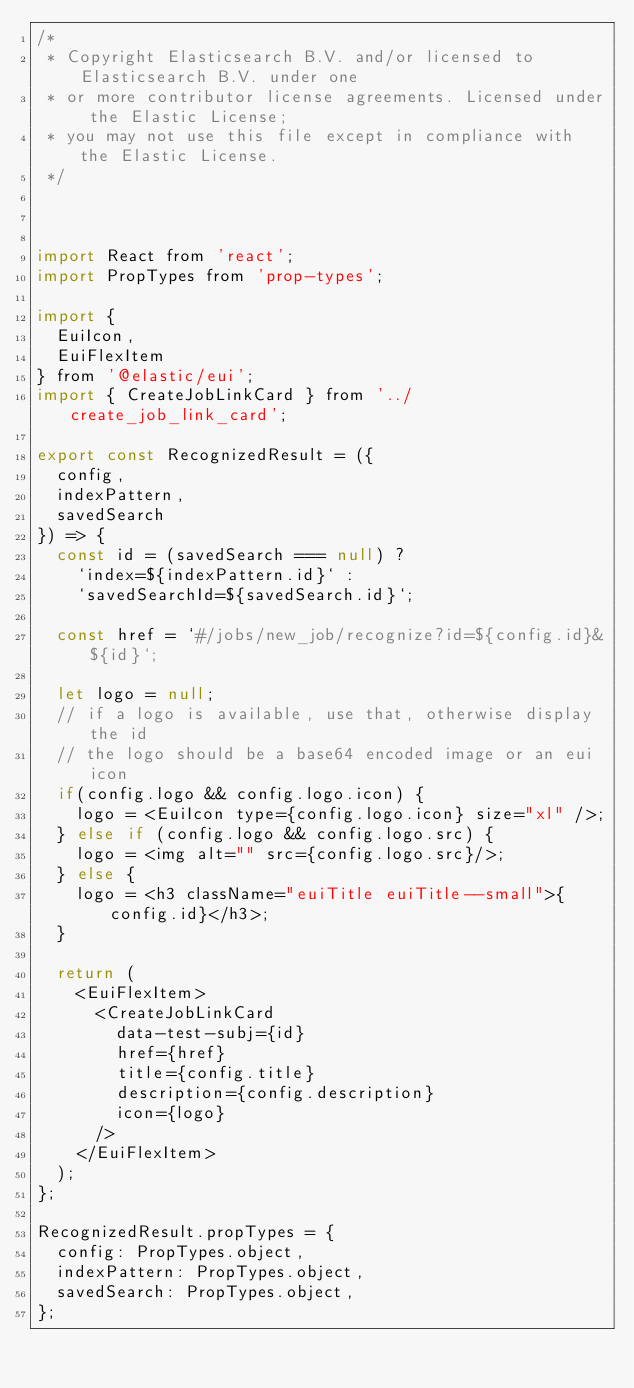<code> <loc_0><loc_0><loc_500><loc_500><_JavaScript_>/*
 * Copyright Elasticsearch B.V. and/or licensed to Elasticsearch B.V. under one
 * or more contributor license agreements. Licensed under the Elastic License;
 * you may not use this file except in compliance with the Elastic License.
 */



import React from 'react';
import PropTypes from 'prop-types';

import {
  EuiIcon,
  EuiFlexItem
} from '@elastic/eui';
import { CreateJobLinkCard } from '../create_job_link_card';

export const RecognizedResult = ({
  config,
  indexPattern,
  savedSearch
}) => {
  const id = (savedSearch === null) ?
    `index=${indexPattern.id}` :
    `savedSearchId=${savedSearch.id}`;

  const href = `#/jobs/new_job/recognize?id=${config.id}&${id}`;

  let logo = null;
  // if a logo is available, use that, otherwise display the id
  // the logo should be a base64 encoded image or an eui icon
  if(config.logo && config.logo.icon) {
    logo = <EuiIcon type={config.logo.icon} size="xl" />;
  } else if (config.logo && config.logo.src) {
    logo = <img alt="" src={config.logo.src}/>;
  } else {
    logo = <h3 className="euiTitle euiTitle--small">{config.id}</h3>;
  }

  return (
    <EuiFlexItem>
      <CreateJobLinkCard
        data-test-subj={id}
        href={href}
        title={config.title}
        description={config.description}
        icon={logo}
      />
    </EuiFlexItem>
  );
};

RecognizedResult.propTypes = {
  config: PropTypes.object,
  indexPattern: PropTypes.object,
  savedSearch: PropTypes.object,
};
</code> 